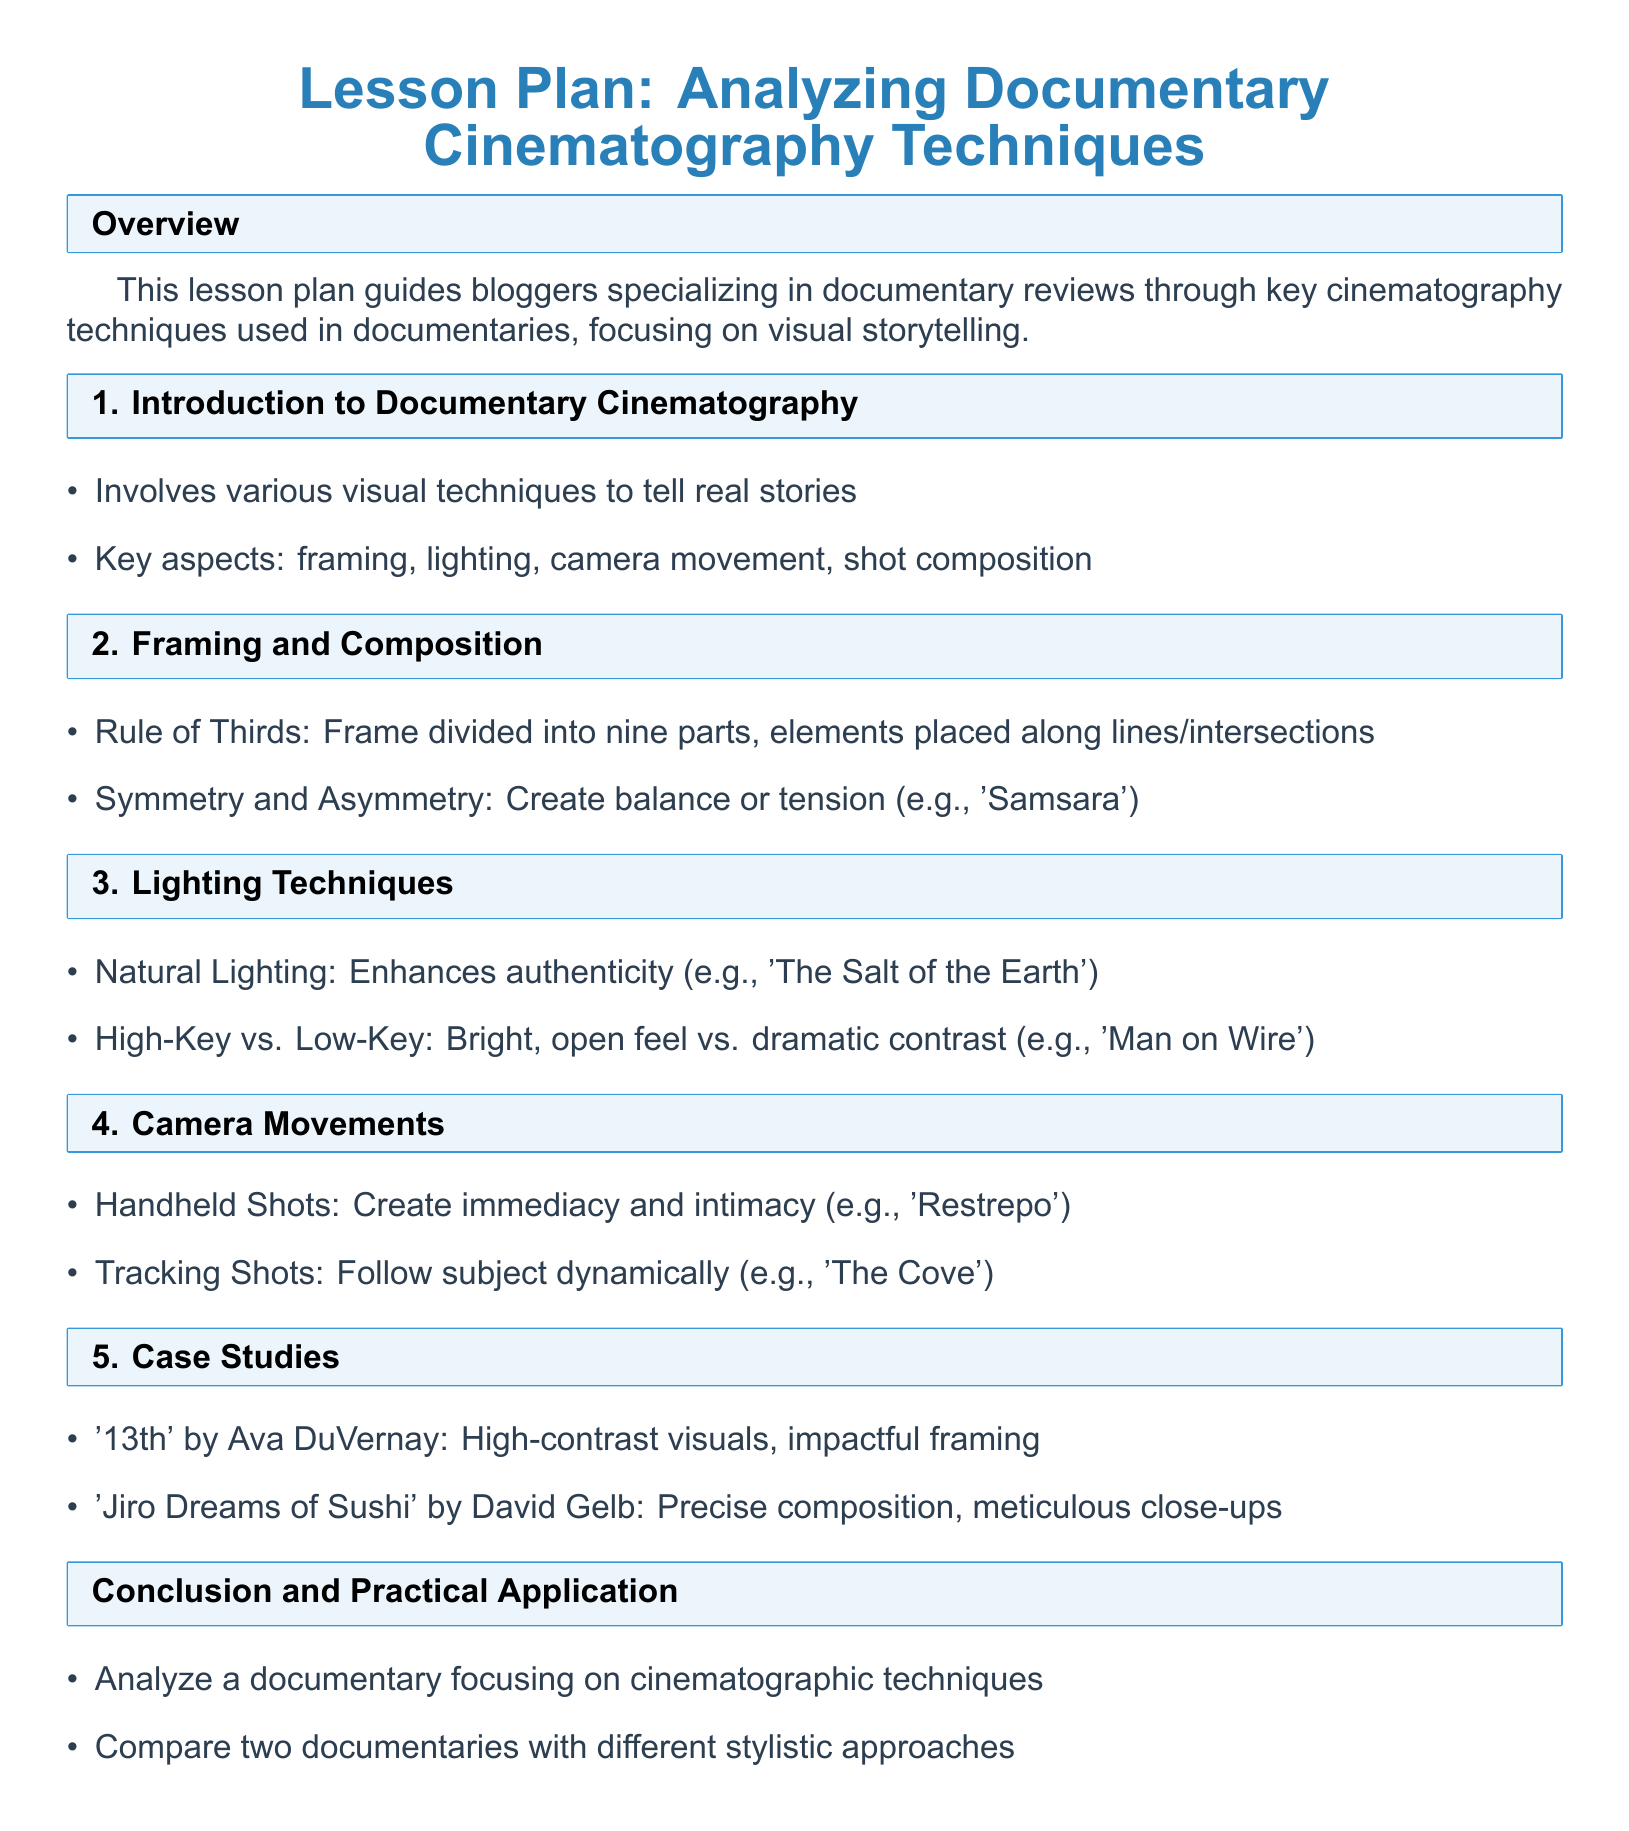What is the title of the lesson plan? The title of the lesson plan is explicitly stated at the beginning of the document.
Answer: Analyzing Documentary Cinematography Techniques What are the key aspects of documentary cinematography mentioned? Key aspects are detailed in the introduction section, focusing on various visual techniques.
Answer: Framing, lighting, camera movement, shot composition Which documentary is noted for using high-contrast visuals? The case studies section lists notable documentaries, including one with high-contrast visuals.
Answer: 13th What lighting technique enhances authenticity in documentaries? The lighting techniques section describes various approaches, one of which emphasizes authenticity.
Answer: Natural Lighting What camera movement creates immediacy and intimacy? The document discusses specific camera movements, identifying one that evokes a certain experience.
Answer: Handheld Shots Which documentary is recognized for its precise composition? The case studies section highlights documentaries with notable cinematographic approaches.
Answer: Jiro Dreams of Sushi How many main sections are there in the lesson plan? The overall structure of the document presents several main sections covering different topics.
Answer: 6 What is the conclusion's practical application task? The conclusion section outlines a task aimed at reinforcing the lesson's concepts through practical application.
Answer: Analyze a documentary focusing on cinematographic techniques What does the Rule of Thirds involve? The framing and composition section explains this technique clearly, detailing its method.
Answer: Frame divided into nine parts 